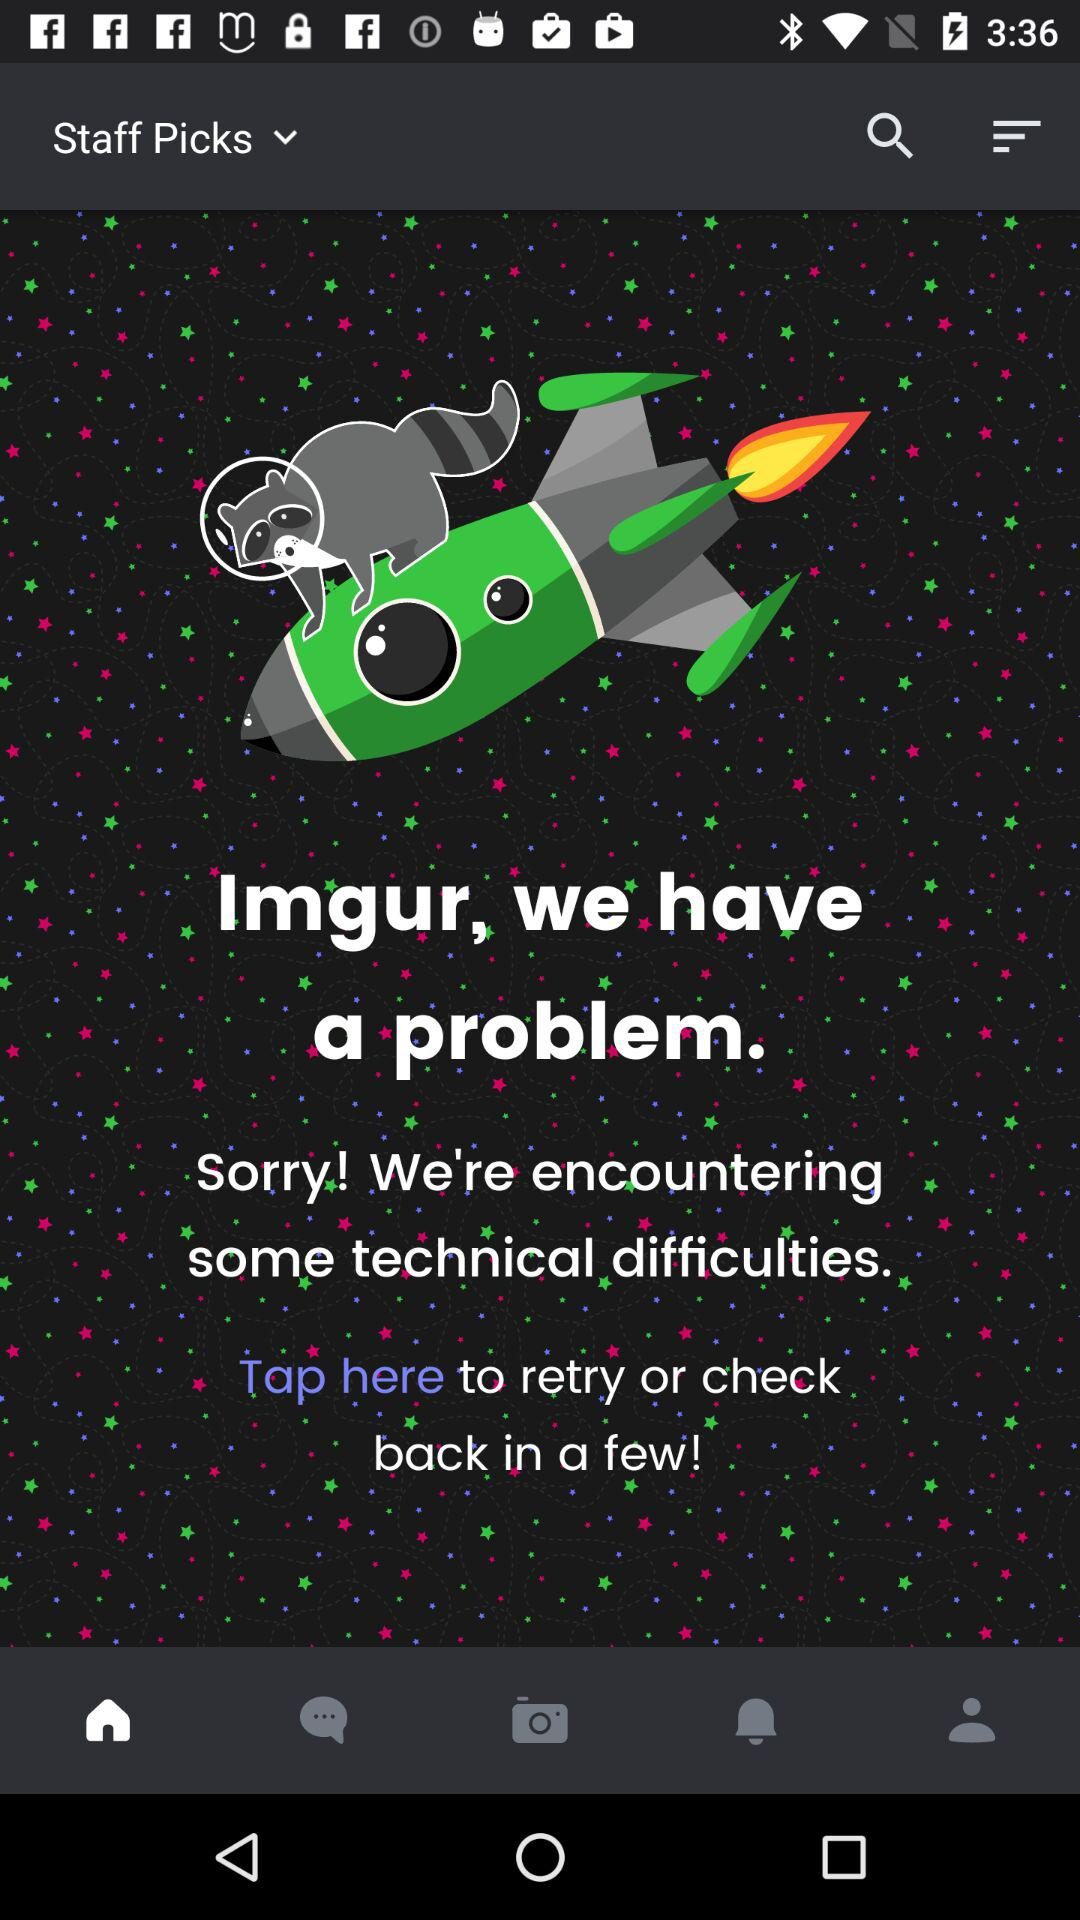Which tab am I on? You are on "Home" tab. 